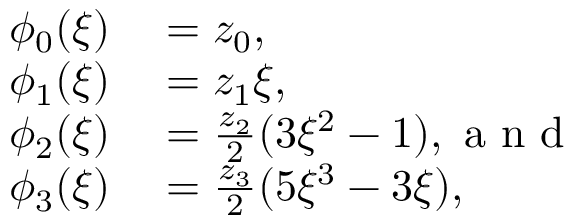<formula> <loc_0><loc_0><loc_500><loc_500>\begin{array} { r l } { \phi _ { 0 } ( \xi ) } & = z _ { 0 } , } \\ { \phi _ { 1 } ( \xi ) } & = z _ { 1 } \xi , } \\ { \phi _ { 2 } ( \xi ) } & = \frac { z _ { 2 } } { 2 } ( 3 \xi ^ { 2 } - 1 ) , a n d } \\ { \phi _ { 3 } ( \xi ) } & = \frac { z _ { 3 } } { 2 } ( 5 \xi ^ { 3 } - 3 \xi ) , } \end{array}</formula> 